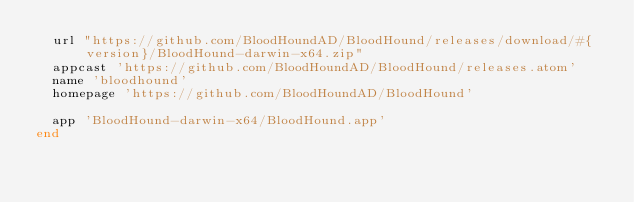Convert code to text. <code><loc_0><loc_0><loc_500><loc_500><_Ruby_>  url "https://github.com/BloodHoundAD/BloodHound/releases/download/#{version}/BloodHound-darwin-x64.zip"
  appcast 'https://github.com/BloodHoundAD/BloodHound/releases.atom'
  name 'bloodhound'
  homepage 'https://github.com/BloodHoundAD/BloodHound'

  app 'BloodHound-darwin-x64/BloodHound.app'
end
</code> 